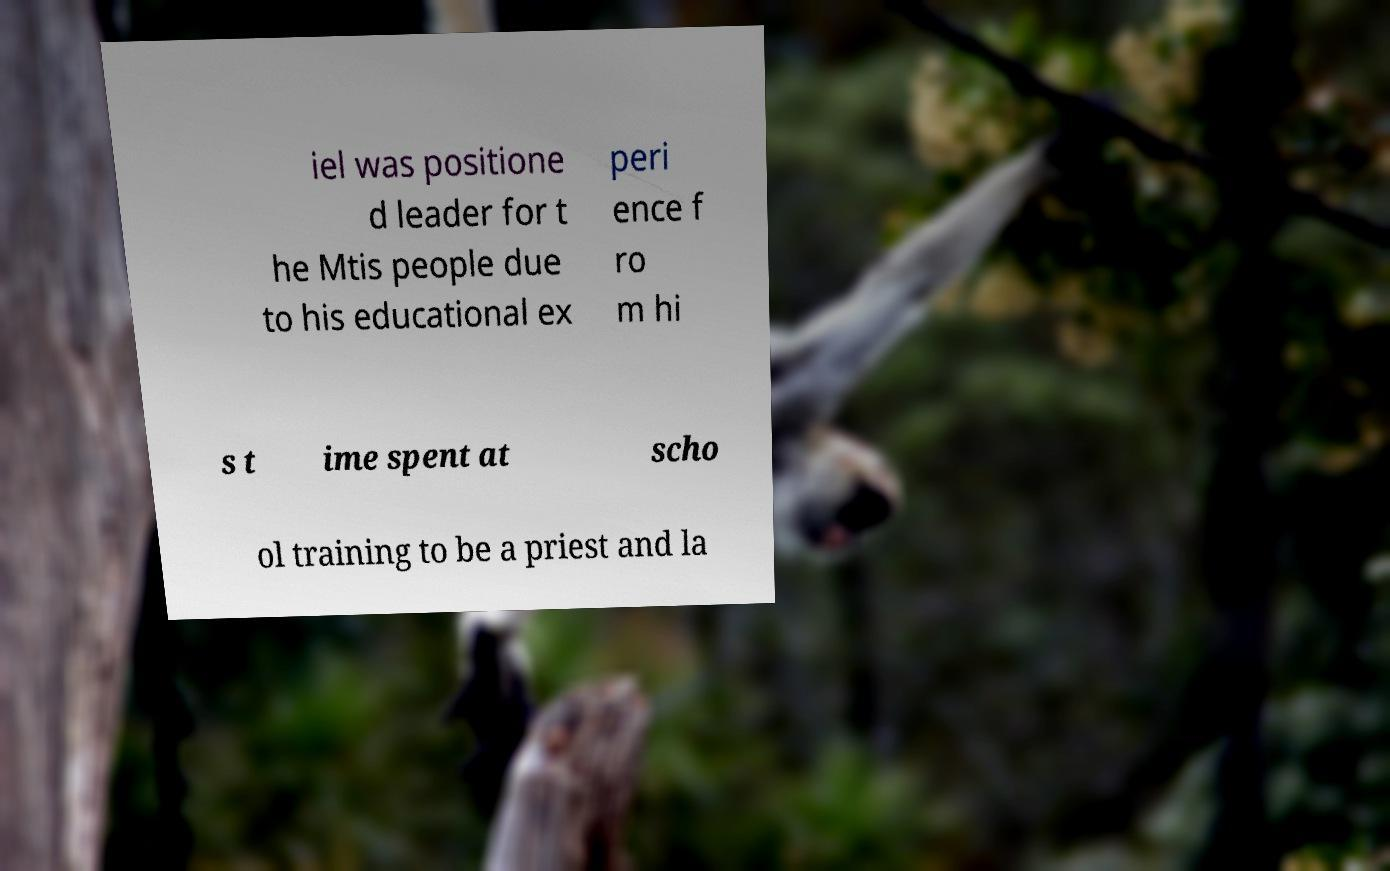Could you extract and type out the text from this image? iel was positione d leader for t he Mtis people due to his educational ex peri ence f ro m hi s t ime spent at scho ol training to be a priest and la 